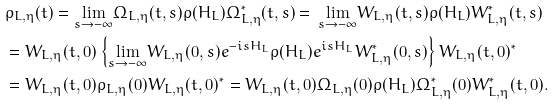Convert formula to latex. <formula><loc_0><loc_0><loc_500><loc_500>& \rho _ { L , \eta } ( t ) = \underset { s \rightarrow - \infty } { \lim } \Omega _ { L , \eta } ( t , s ) \rho ( H _ { L } ) \Omega _ { L , \eta } ^ { * } ( t , s ) = \, \underset { s \rightarrow - \infty } { \lim } W _ { L , \eta } ( t , s ) \rho ( H _ { L } ) W _ { L , \eta } ^ { * } ( t , s ) \\ & = W _ { L , \eta } ( t , 0 ) \left \{ \underset { s \rightarrow - \infty } { \lim } W _ { L , \eta } ( 0 , s ) e ^ { - i s H _ { L } } \rho ( H _ { L } ) e ^ { i s H _ { L } } W _ { L , \eta } ^ { * } ( 0 , s ) \right \} W _ { L , \eta } ( t , 0 ) ^ { * } \\ & = W _ { L , \eta } ( t , 0 ) \rho _ { L , \eta } ( 0 ) W _ { L , \eta } ( t , 0 ) ^ { * } = W _ { L , \eta } ( t , 0 ) \Omega _ { L , \eta } ( 0 ) \rho ( H _ { L } ) \Omega _ { L , \eta } ^ { * } ( 0 ) W _ { L , \eta } ^ { * } ( t , 0 ) .</formula> 